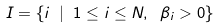Convert formula to latex. <formula><loc_0><loc_0><loc_500><loc_500>I = \{ i \ | \ 1 \leq i \leq N , \ \beta _ { i } > 0 \}</formula> 